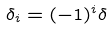Convert formula to latex. <formula><loc_0><loc_0><loc_500><loc_500>\delta _ { i } = ( - 1 ) ^ { i } \delta</formula> 